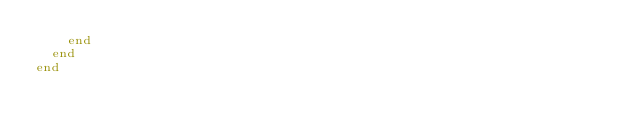Convert code to text. <code><loc_0><loc_0><loc_500><loc_500><_Ruby_>    end
  end
end</code> 